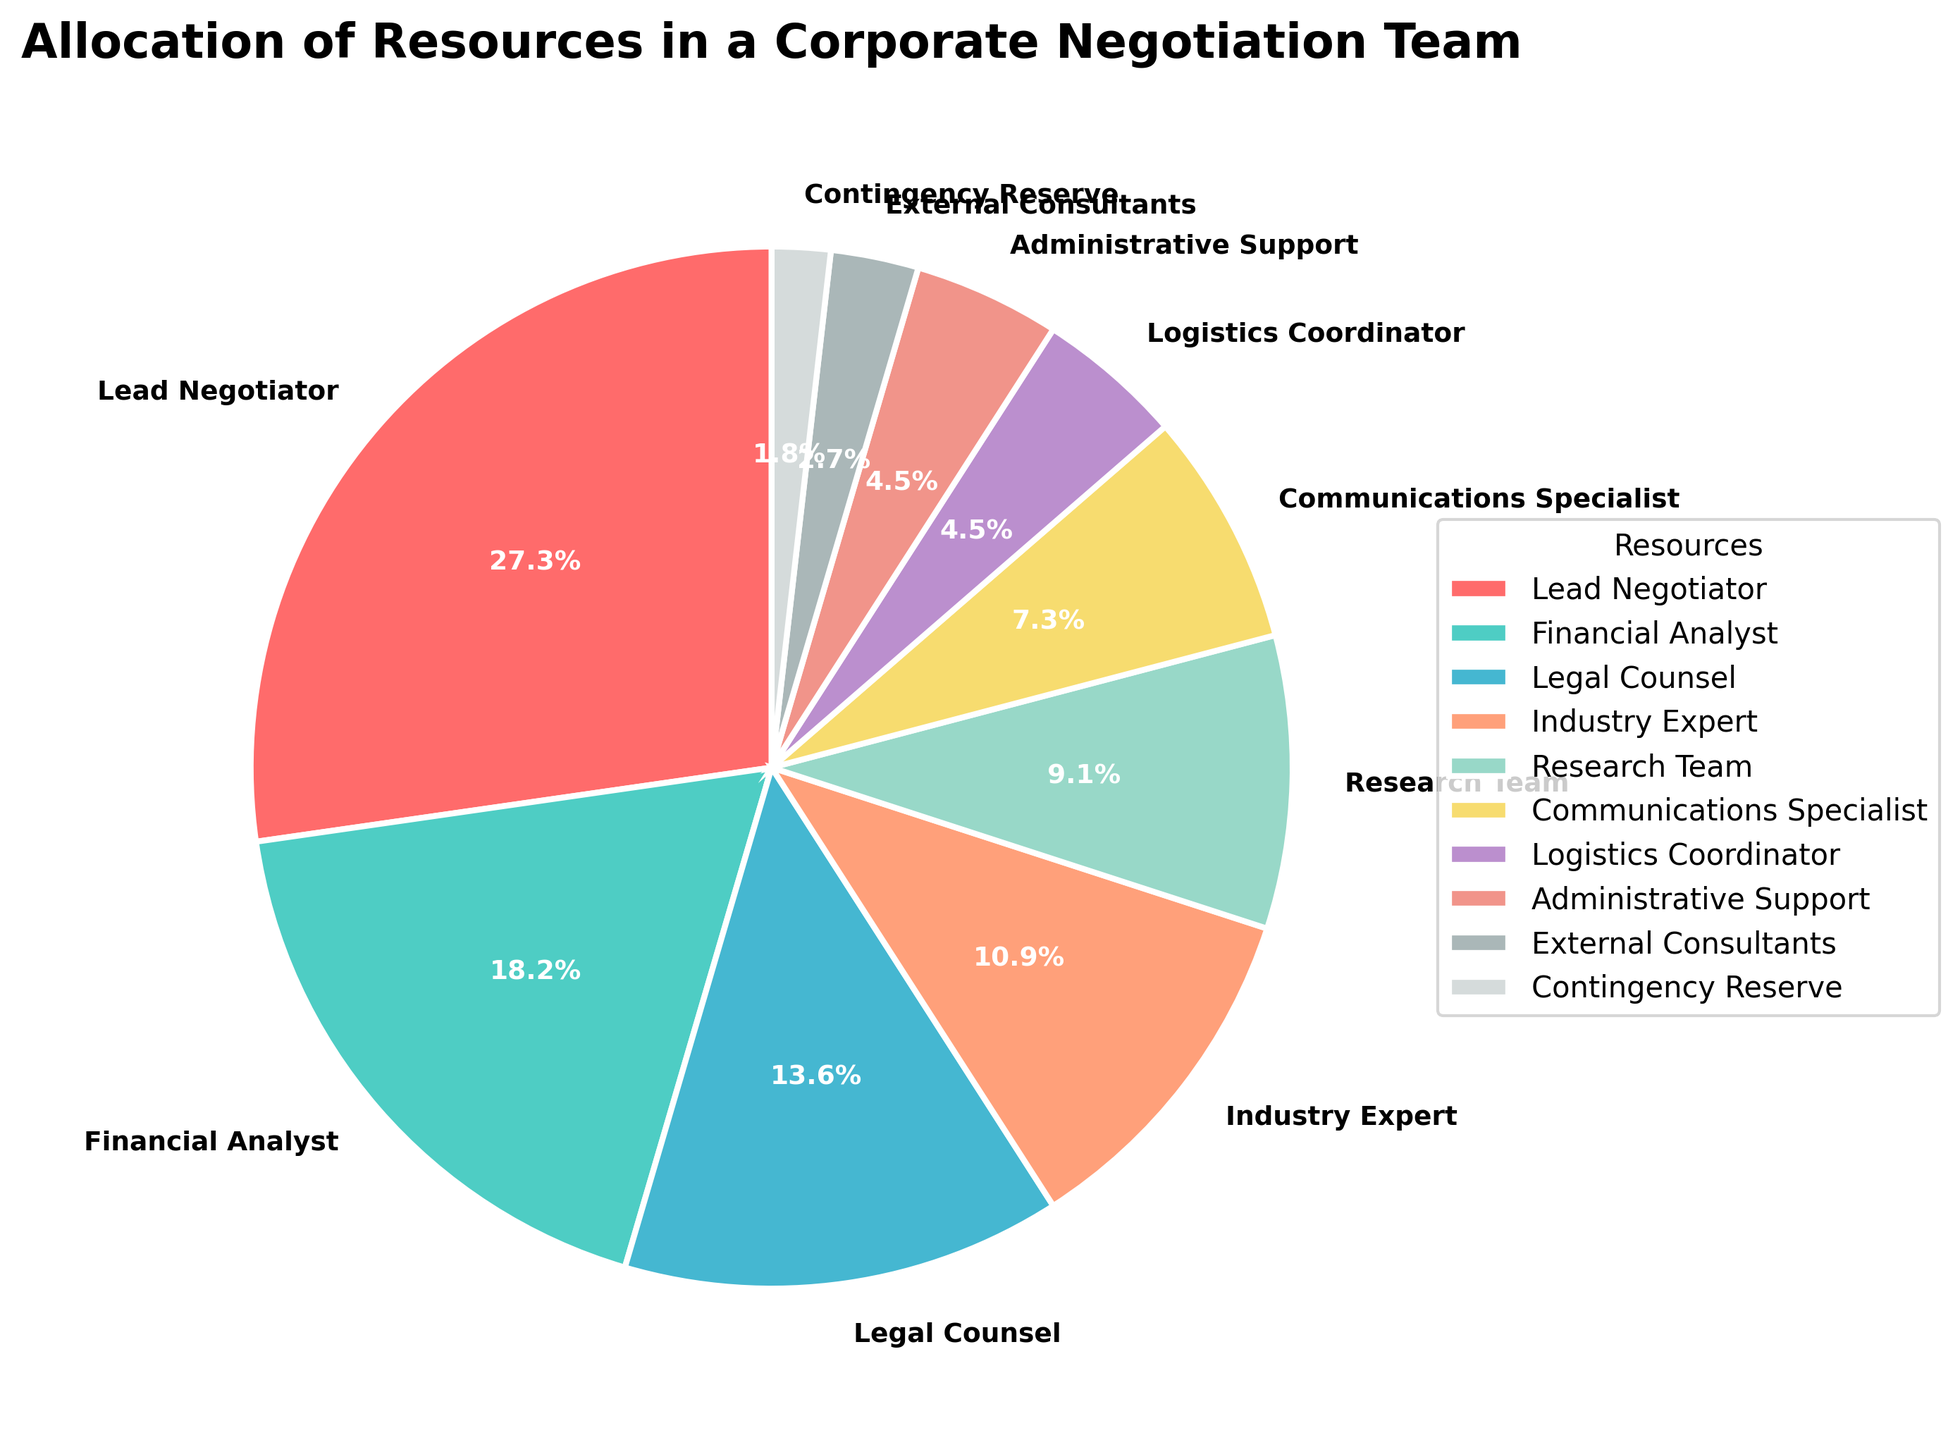What percentage of resources is allocated to Industry Expert and Research Team combined? To find the combined percentage, add the percentage allocated to the Industry Expert (12%) and the Research Team (10%). Therefore, 12% + 10% = 22%.
Answer: 22% Which resource has the highest allocation? The resource with the highest allocation is the one with the largest percentage. The Lead Negotiator has the highest allocation at 30%.
Answer: Lead Negotiator Which resource category has the smallest slice in the pie chart? The smallest slice in the pie chart represents the resource with the least percentage. The Contingency Reserve has the smallest allocation at 2%.
Answer: Contingency Reserve How much larger is the allocation for the Legal Counsel compared to the Logistics Coordinator? To find how much larger the allocation for the Legal Counsel is compared to the Logistics Coordinator, subtract the Logistics Coordinator's percentage (5%) from the Legal Counsel's percentage (15%). Therefore, 15% - 5% = 10%.
Answer: 10% Is the combined allocation of Financial Analyst and Communications Specialist greater than the Lead Negotiator? To determine this, add the percentages of Financial Analyst (20%) and Communications Specialist (8%), which equals 28%, and compare to the Lead Negotiator's allocation (30%). Since 28% is less than 30%, the combined allocation is not greater.
Answer: No Which three resource categories together make up just over half of the total allocation? Identify three categories whose combined percentages exceed 50%. The Lead Negotiator (30%), Financial Analyst (20%), and Legal Counsel (15%) together total 65%.
Answer: Lead Negotiator, Financial Analyst, and Legal Counsel What is the average percentage allocation of the Administrative Support, External Consultants, and Contingency Reserve? To find the average, sum the percentages of these three resources (5% + 3% + 2%), which equals 10%, and divide by the number of resources (3). Therefore, 10% / 3 ≈ 3.33%.
Answer: 3.33% How does the percentage allocation of the Research Team compare to that of the Communications Specialist? The percentage allocation for the Research Team (10%) is 2% more than that for the Communications Specialist (8%).
Answer: 2% Is the allocation for the Financial Analyst more than twice the allocation for the Logistics Coordinator? The allocation for the Financial Analyst is 20%, and for the Logistics Coordinator, it is 5%. Since 20% is more than twice 5% (which would be 10%), the answer is yes.
Answer: Yes Which resources have the same allocation percentages? By examining the pie chart, we can see that both the Logistics Coordinator and Administrative Support have the same allocation percentages of 5%.
Answer: Logistics Coordinator and Administrative Support 